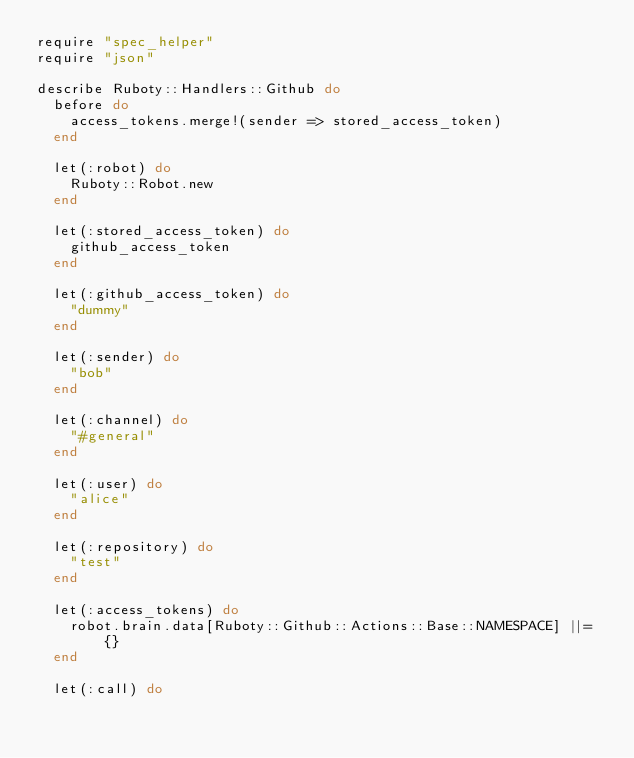Convert code to text. <code><loc_0><loc_0><loc_500><loc_500><_Ruby_>require "spec_helper"
require "json"

describe Ruboty::Handlers::Github do
  before do
    access_tokens.merge!(sender => stored_access_token)
  end

  let(:robot) do
    Ruboty::Robot.new
  end

  let(:stored_access_token) do
    github_access_token
  end

  let(:github_access_token) do
    "dummy"
  end

  let(:sender) do
    "bob"
  end

  let(:channel) do
    "#general"
  end

  let(:user) do
    "alice"
  end

  let(:repository) do
    "test"
  end

  let(:access_tokens) do
    robot.brain.data[Ruboty::Github::Actions::Base::NAMESPACE] ||= {}
  end

  let(:call) do</code> 